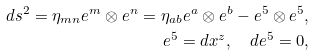Convert formula to latex. <formula><loc_0><loc_0><loc_500><loc_500>d s ^ { 2 } = \eta _ { m n } e ^ { m } \otimes e ^ { n } = \eta _ { a b } e ^ { a } \otimes e ^ { b } - e ^ { 5 } \otimes e ^ { 5 } , \\ e ^ { 5 } = d x ^ { z } , \quad d e ^ { 5 } = 0 ,</formula> 